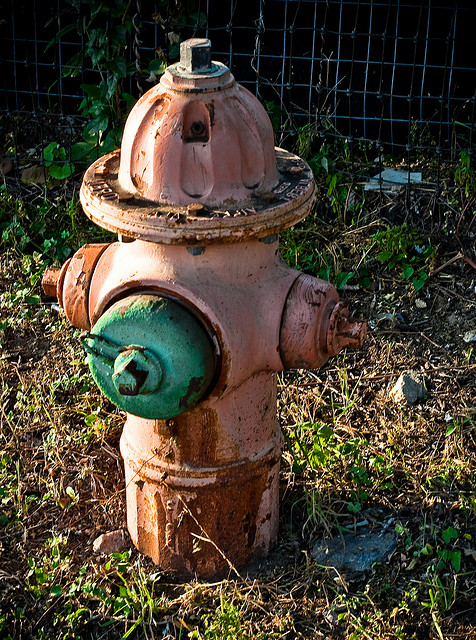<image>What chemical process caused the discoloration? I'm not sure what chemical process caused the discoloration. It could be rust or oxidation. What is the fence made of in the background? It is unclear what the fence is made of. It could be wire or metal. What chemical process caused the discoloration? I don't know what chemical process caused the discoloration. It could be rust, oxidation or rusting. What is the fence made of in the background? I am not sure what the fence in the background is made of. It can be seen wire, plaster, metal or barb wire. 